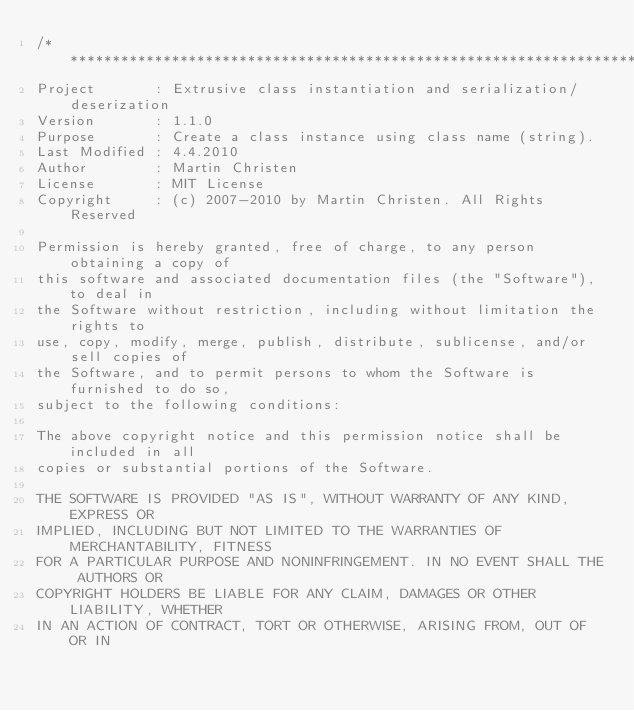<code> <loc_0><loc_0><loc_500><loc_500><_C++_>/*******************************************************************************
Project       : Extrusive class instantiation and serialization/deserization
Version       : 1.1.0
Purpose       : Create a class instance using class name (string).
Last Modified : 4.4.2010
Author        : Martin Christen
License       : MIT License
Copyright     : (c) 2007-2010 by Martin Christen. All Rights Reserved

Permission is hereby granted, free of charge, to any person obtaining a copy of 
this software and associated documentation files (the "Software"), to deal in 
the Software without restriction, including without limitation the rights to 
use, copy, modify, merge, publish, distribute, sublicense, and/or sell copies of 
the Software, and to permit persons to whom the Software is furnished to do so, 
subject to the following conditions:

The above copyright notice and this permission notice shall be included in all 
copies or substantial portions of the Software.

THE SOFTWARE IS PROVIDED "AS IS", WITHOUT WARRANTY OF ANY KIND, EXPRESS OR 
IMPLIED, INCLUDING BUT NOT LIMITED TO THE WARRANTIES OF MERCHANTABILITY, FITNESS 
FOR A PARTICULAR PURPOSE AND NONINFRINGEMENT. IN NO EVENT SHALL THE AUTHORS OR 
COPYRIGHT HOLDERS BE LIABLE FOR ANY CLAIM, DAMAGES OR OTHER LIABILITY, WHETHER 
IN AN ACTION OF CONTRACT, TORT OR OTHERWISE, ARISING FROM, OUT OF OR IN </code> 